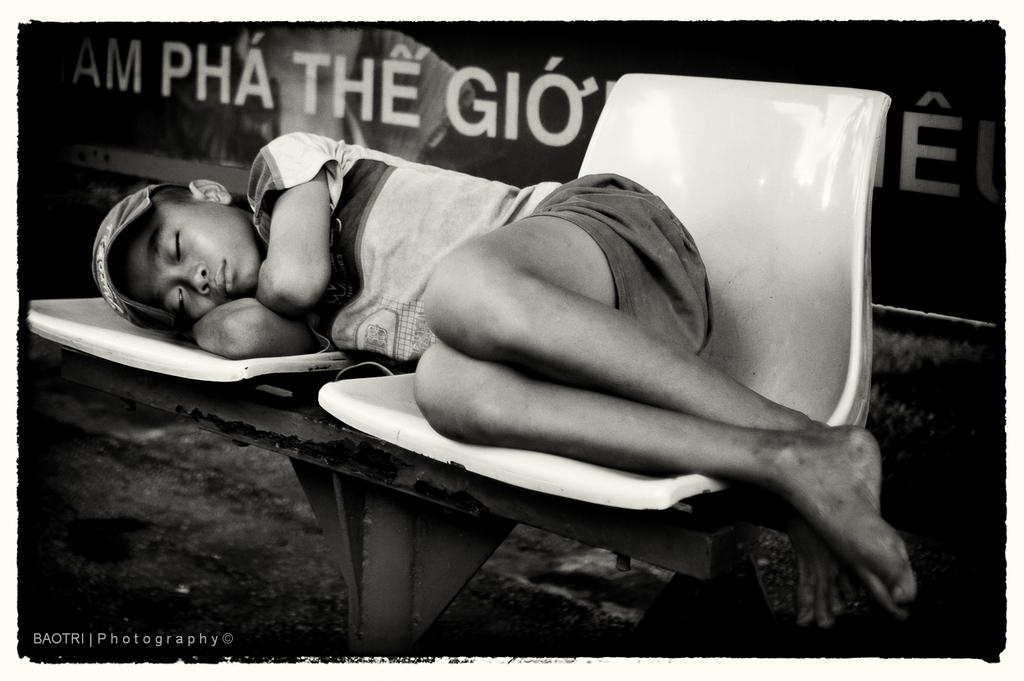Who is in the picture? There is a boy in the picture. What is the boy doing in the picture? The boy is sleeping on a chair. What is the boy wearing in the picture? The boy is wearing a cap, a t-shirt, and shorts. What can be seen on the wall in the picture? There is a banner on the wall. Is there any additional information about the image itself? Yes, there is a watermark in the bottom of the image. What type of bear can be seen using the water in the image? There is no bear present in the image, and no water is visible for a bear to use. 